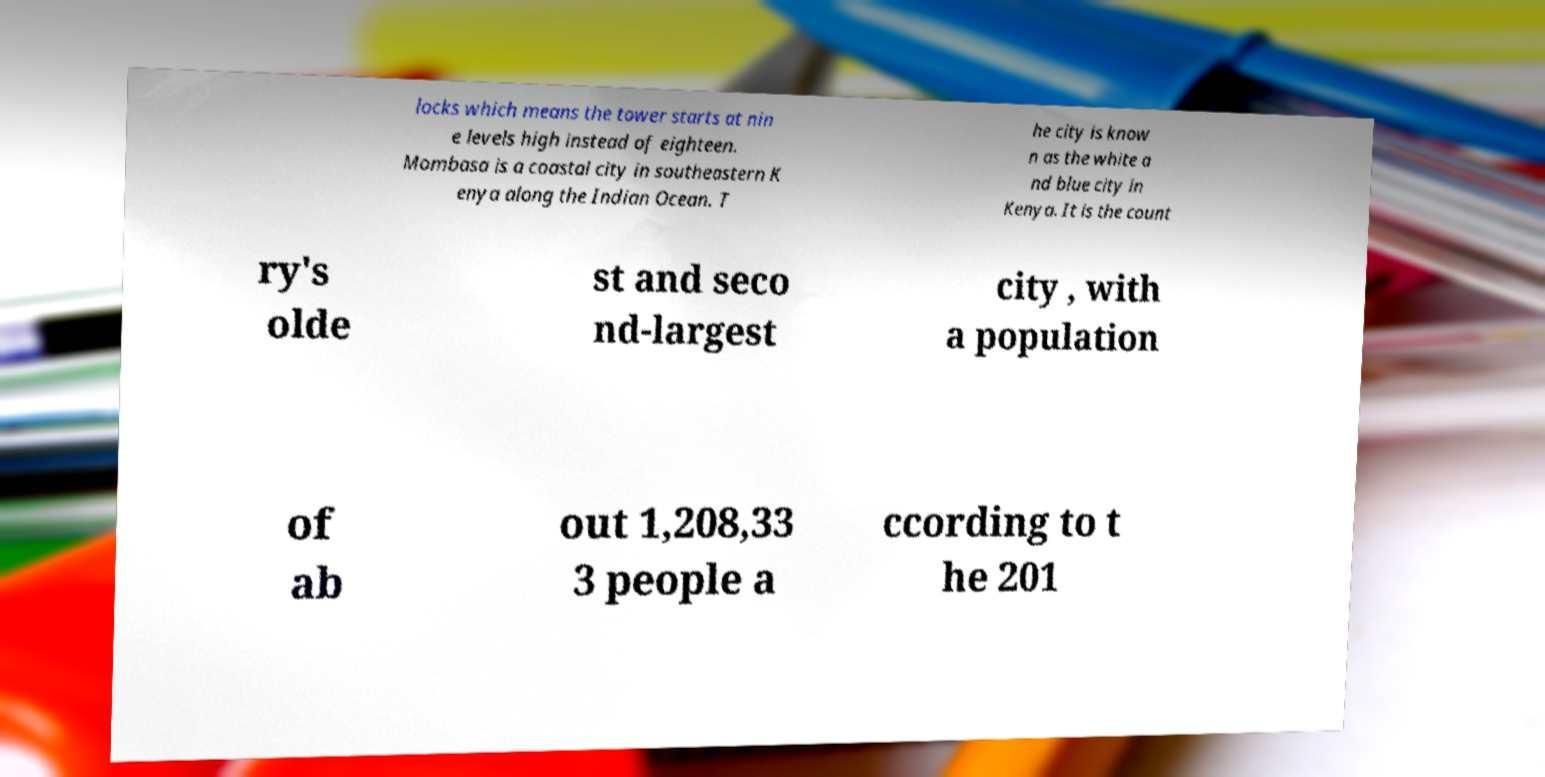Please read and relay the text visible in this image. What does it say? locks which means the tower starts at nin e levels high instead of eighteen. Mombasa is a coastal city in southeastern K enya along the Indian Ocean. T he city is know n as the white a nd blue city in Kenya. It is the count ry's olde st and seco nd-largest city , with a population of ab out 1,208,33 3 people a ccording to t he 201 